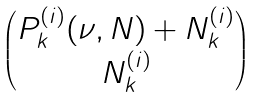Convert formula to latex. <formula><loc_0><loc_0><loc_500><loc_500>\begin{pmatrix} P _ { k } ^ { ( i ) } ( \nu , N ) + N _ { k } ^ { ( i ) } \\ N _ { k } ^ { ( i ) } \end{pmatrix}</formula> 